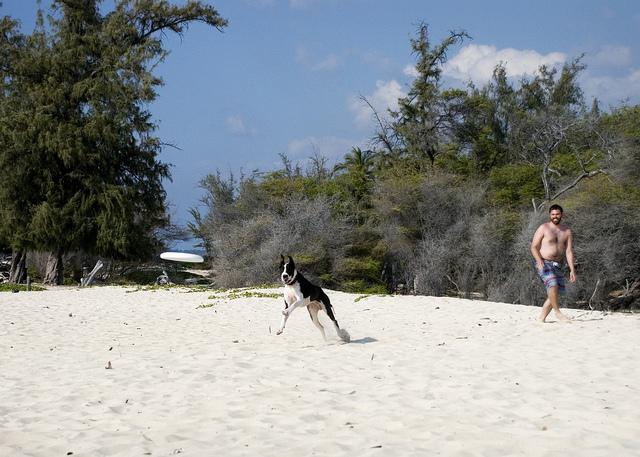What is the dog chasing?
Short answer required. Frisbee. Which game are they playing?
Write a very short answer. Fetch. How many people are there?
Short answer required. 1. Is the dog sitting?
Concise answer only. No. What type of animal is sitting on the sand?
Keep it brief. Dog. 